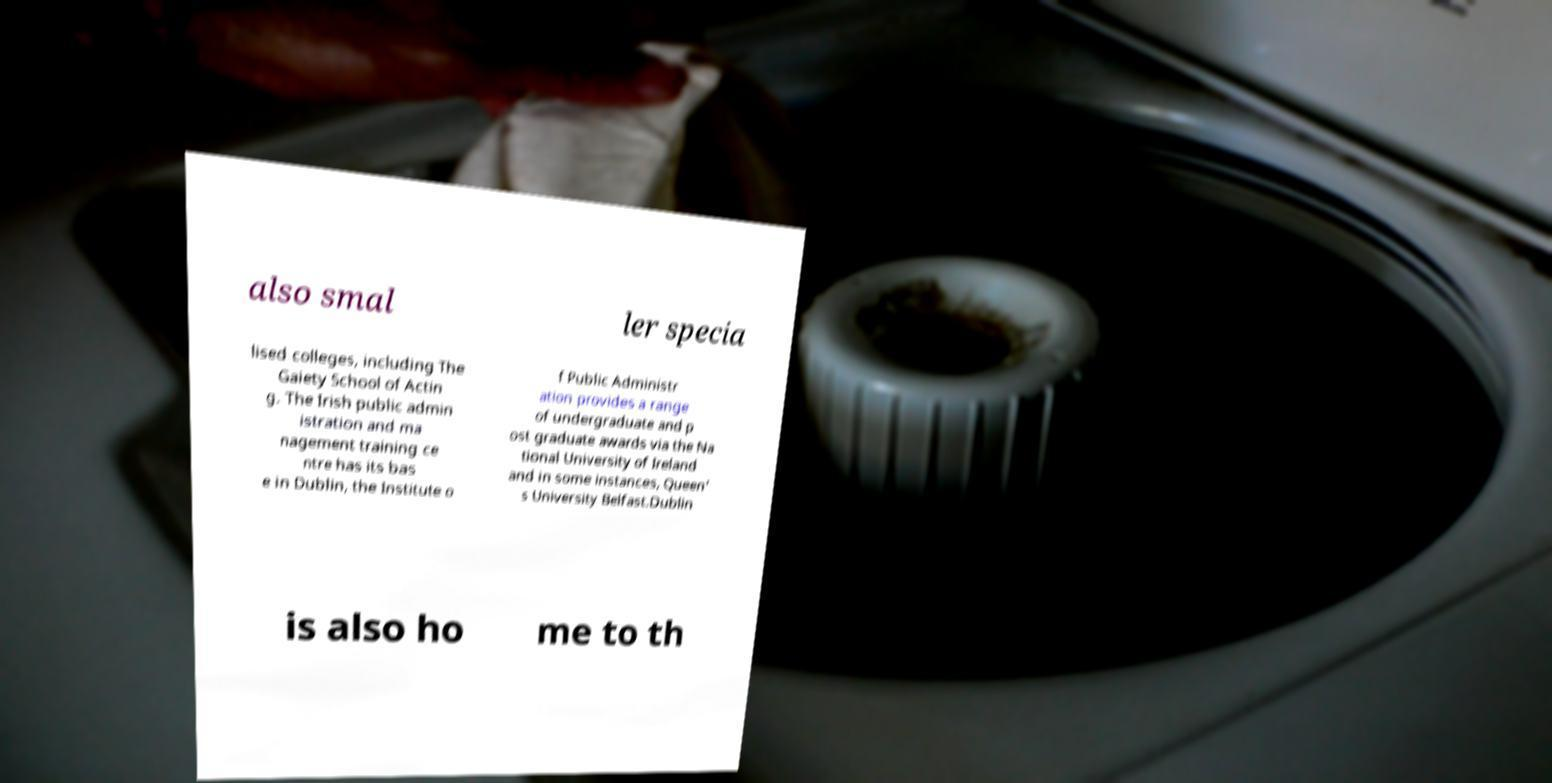Can you read and provide the text displayed in the image?This photo seems to have some interesting text. Can you extract and type it out for me? also smal ler specia lised colleges, including The Gaiety School of Actin g. The Irish public admin istration and ma nagement training ce ntre has its bas e in Dublin, the Institute o f Public Administr ation provides a range of undergraduate and p ost graduate awards via the Na tional University of Ireland and in some instances, Queen' s University Belfast.Dublin is also ho me to th 